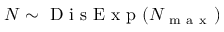<formula> <loc_0><loc_0><loc_500><loc_500>N \sim D i s E x p ( N _ { m a x } )</formula> 